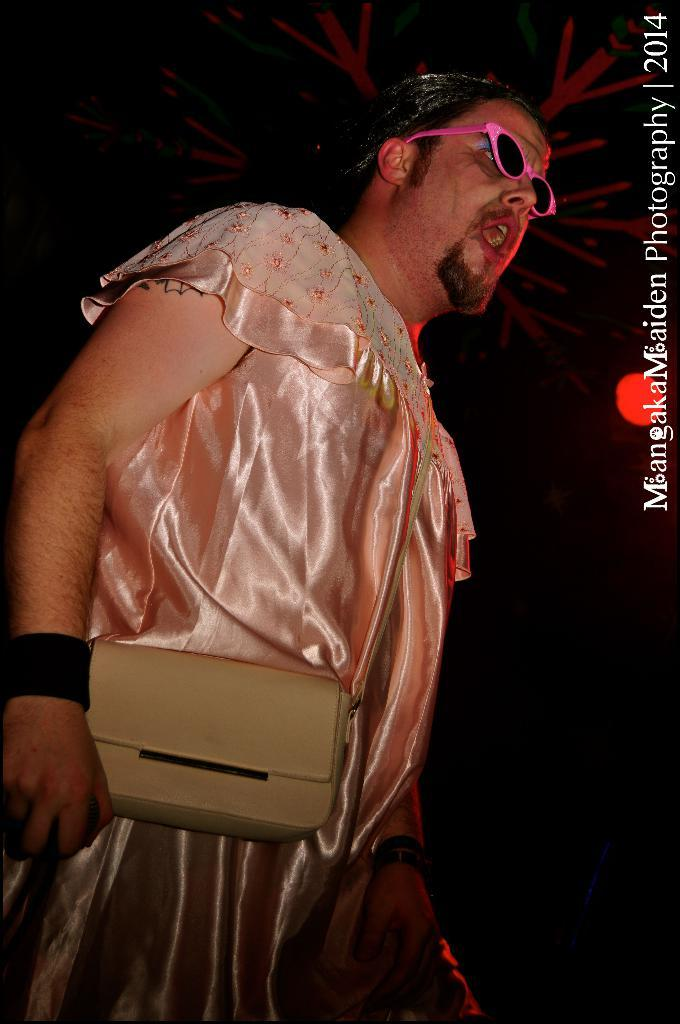What is the main subject of the image? There is a man standing in the image. What is the man doing in the image? The man is speaking in the image. Are there any objects visible in the image besides the man? Yes, there is a handbag visible in the image. Can you see a crow interacting with the man in the image? There is no crow present in the image, and the man is not interacting with a stranger, can be observed. 